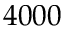<formula> <loc_0><loc_0><loc_500><loc_500>4 0 0 0</formula> 